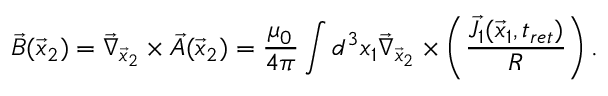<formula> <loc_0><loc_0><loc_500><loc_500>\vec { B } ( \vec { x } _ { 2 } ) = \vec { \nabla } _ { \vec { x } _ { 2 } } \times \vec { A } ( \vec { x } _ { 2 } ) = \frac { \mu _ { 0 } } { 4 \pi } \int d ^ { 3 } x _ { 1 } \vec { \nabla } _ { \vec { x } _ { 2 } } \times \left ( \frac { \vec { J } _ { 1 } ( \vec { x } _ { 1 } , t _ { r e t } ) } { R } \right ) .</formula> 